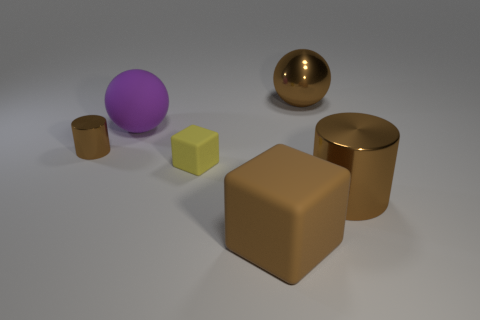What number of cubes are big shiny things or brown metal objects?
Make the answer very short. 0. There is a block that is the same size as the rubber ball; what color is it?
Ensure brevity in your answer.  Brown. Is there anything else that is the same shape as the tiny yellow object?
Provide a succinct answer. Yes. The large rubber object that is the same shape as the small yellow matte object is what color?
Make the answer very short. Brown. What number of objects are either tiny yellow things or balls that are on the left side of the big brown rubber block?
Offer a very short reply. 2. Are there fewer large brown matte things that are behind the tiny cylinder than matte spheres?
Your answer should be compact. Yes. There is a cylinder that is left of the brown metal object that is behind the brown shiny cylinder that is on the left side of the large purple matte sphere; what is its size?
Provide a succinct answer. Small. What is the color of the shiny thing that is both right of the small block and to the left of the large shiny cylinder?
Make the answer very short. Brown. What number of big rubber cubes are there?
Keep it short and to the point. 1. Are the large purple thing and the small brown object made of the same material?
Your answer should be compact. No. 